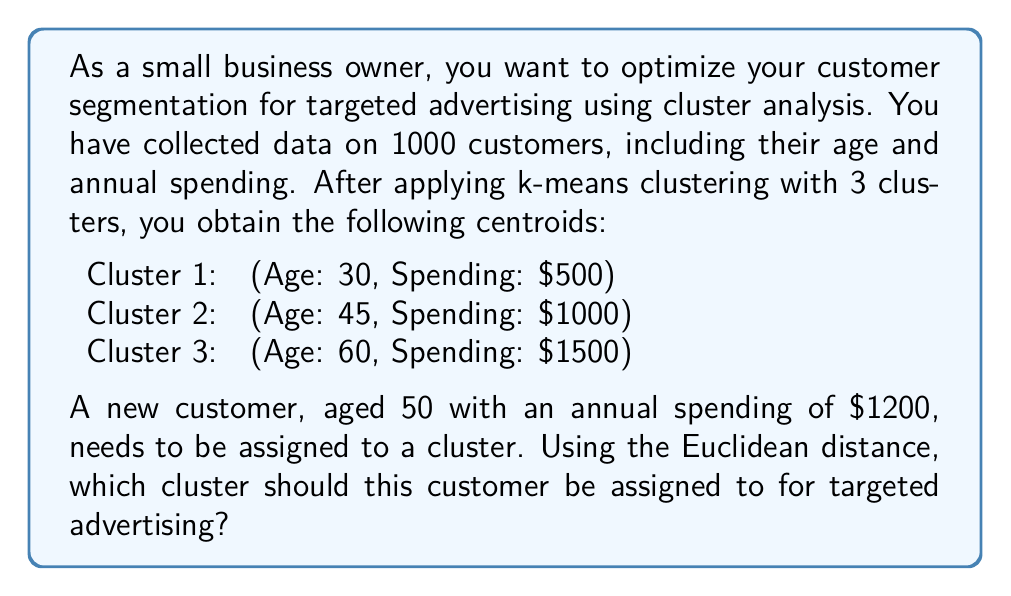Provide a solution to this math problem. To determine which cluster the new customer should be assigned to, we need to calculate the Euclidean distance between the customer's data point and each cluster centroid. The cluster with the smallest distance will be the one to which the customer is assigned.

The Euclidean distance formula in two dimensions is:

$$ d = \sqrt{(x_1 - x_2)^2 + (y_1 - y_2)^2} $$

Where $(x_1, y_1)$ is the customer's data point and $(x_2, y_2)$ is the cluster centroid.

Let's calculate the distance to each cluster:

1. Distance to Cluster 1:
$$ d_1 = \sqrt{(50 - 30)^2 + (1200 - 500)^2} = \sqrt{400 + 490000} = \sqrt{490400} \approx 700.29 $$

2. Distance to Cluster 2:
$$ d_2 = \sqrt{(50 - 45)^2 + (1200 - 1000)^2} = \sqrt{25 + 40000} = \sqrt{40025} \approx 200.06 $$

3. Distance to Cluster 3:
$$ d_3 = \sqrt{(50 - 60)^2 + (1200 - 1500)^2} = \sqrt{100 + 90000} = \sqrt{90100} \approx 300.17 $$

The smallest distance is $d_2 \approx 200.06$, which corresponds to Cluster 2.
Answer: The new customer should be assigned to Cluster 2 for targeted advertising. 